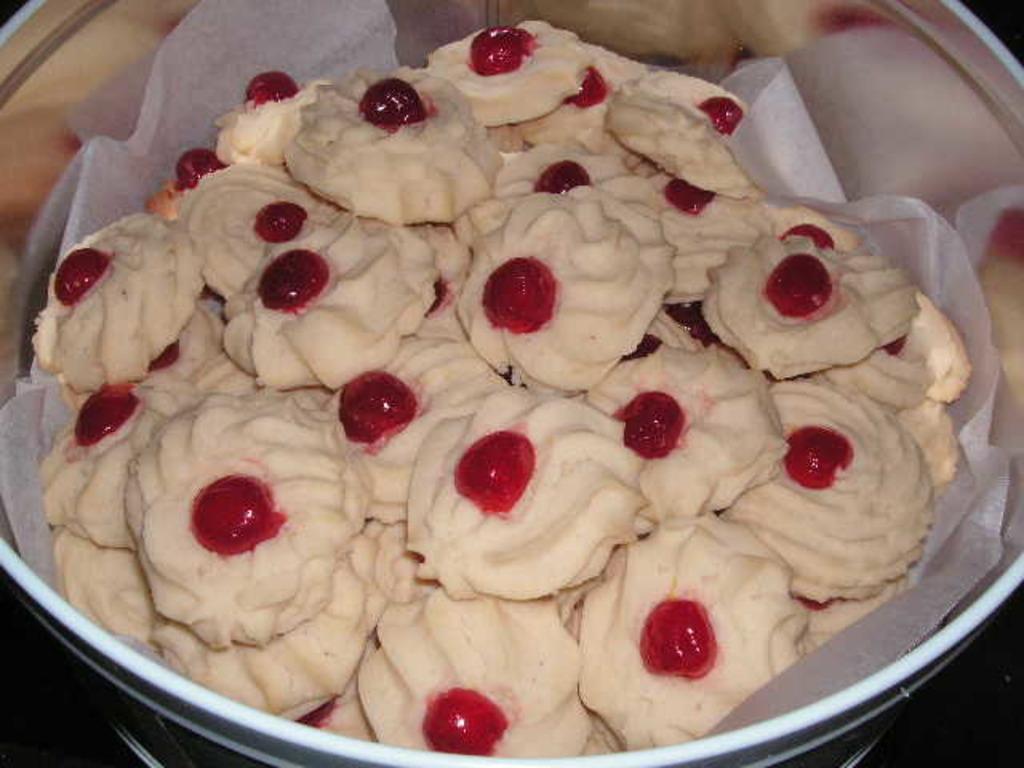Please provide a concise description of this image. In this image I can see an utensil and in it I can see white paper and number of white color things. On these I can see number of red dots. 